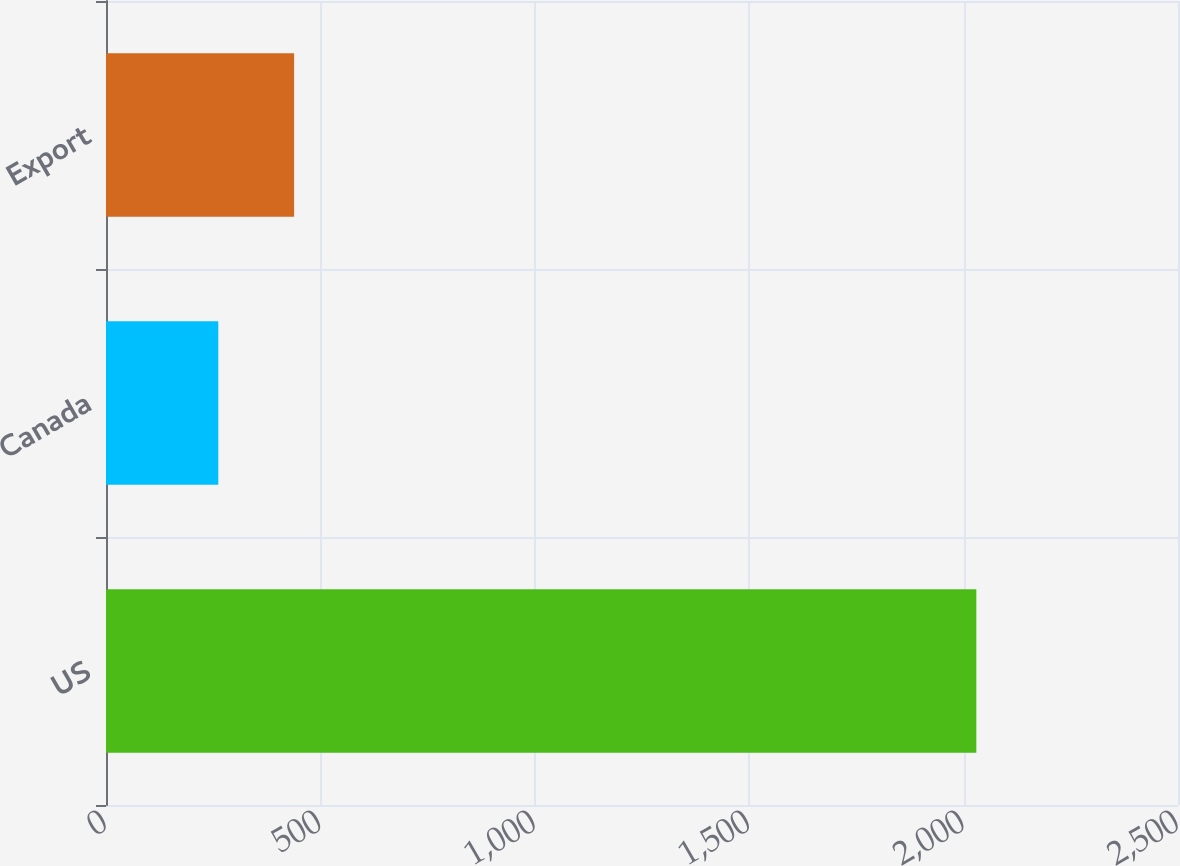Convert chart to OTSL. <chart><loc_0><loc_0><loc_500><loc_500><bar_chart><fcel>US<fcel>Canada<fcel>Export<nl><fcel>2029.7<fcel>261.9<fcel>438.68<nl></chart> 